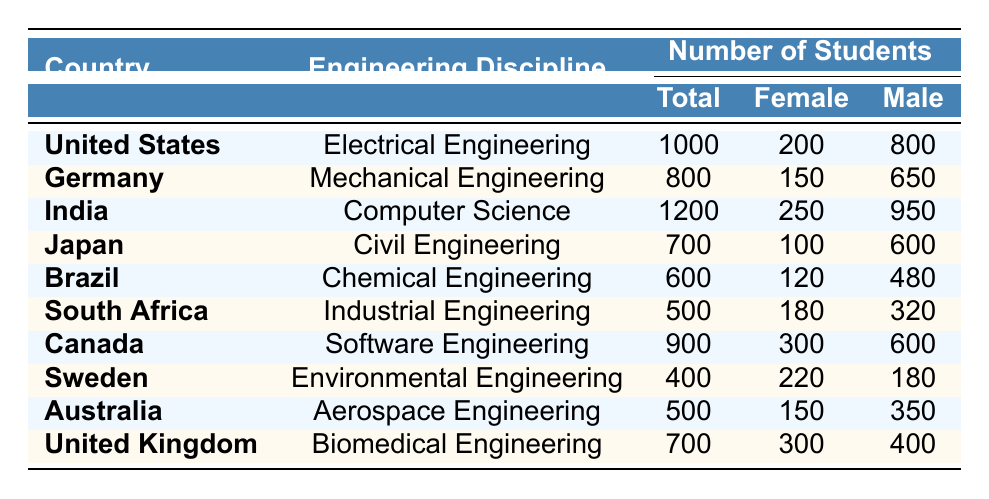What is the total number of students in Electrical Engineering from the United States? The table indicates that there are 1000 students in the Electrical Engineering program from the United States.
Answer: 1000 Which engineering discipline has the highest number of female students? By comparing the "Female Students" column across disciplines, we see that Software Engineering in Canada has 300 female students, which is the highest among the entries.
Answer: Software Engineering What is the percentage of female students in Mechanical Engineering in Germany? The total number of students in Mechanical Engineering is 800 with 150 being female. To calculate the percentage: (150/800) * 100 = 18.75%.
Answer: 18.75% Is there more than one engineering discipline in which females represent over 25% of the total student body? Checking the data, only Software Engineering in Canada and Environmental Engineering in Sweden have over 25% female representation. Therefore, yes, there are two disciplines.
Answer: Yes What is the difference in the number of male students between Civil Engineering in Japan and Industrial Engineering in South Africa? In Japan's Civil Engineering, there are 600 male students, while in South Africa's Industrial Engineering, there are 320 male students. The difference is 600 - 320 = 280.
Answer: 280 What is the combined total of male and female students in Computer Science from India? The total number of students in Computer Science from India is the sum of male and female students: 950 male + 250 female = 1200.
Answer: 1200 Which country has the highest total number of students in the table? The total number of students for each country shows that India has 1200 students, which is the highest of all.
Answer: India What percentage of total students in Environmental Engineering from Sweden are female? For Sweden's Environmental Engineering, there are 400 total students and 220 are female. The percentage is calculated as (220/400) * 100 = 55%.
Answer: 55% 